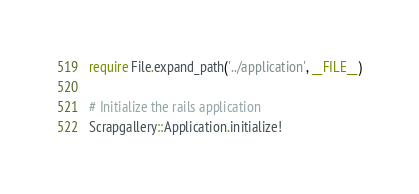Convert code to text. <code><loc_0><loc_0><loc_500><loc_500><_Ruby_>require File.expand_path('../application', __FILE__)

# Initialize the rails application
Scrapgallery::Application.initialize!
</code> 